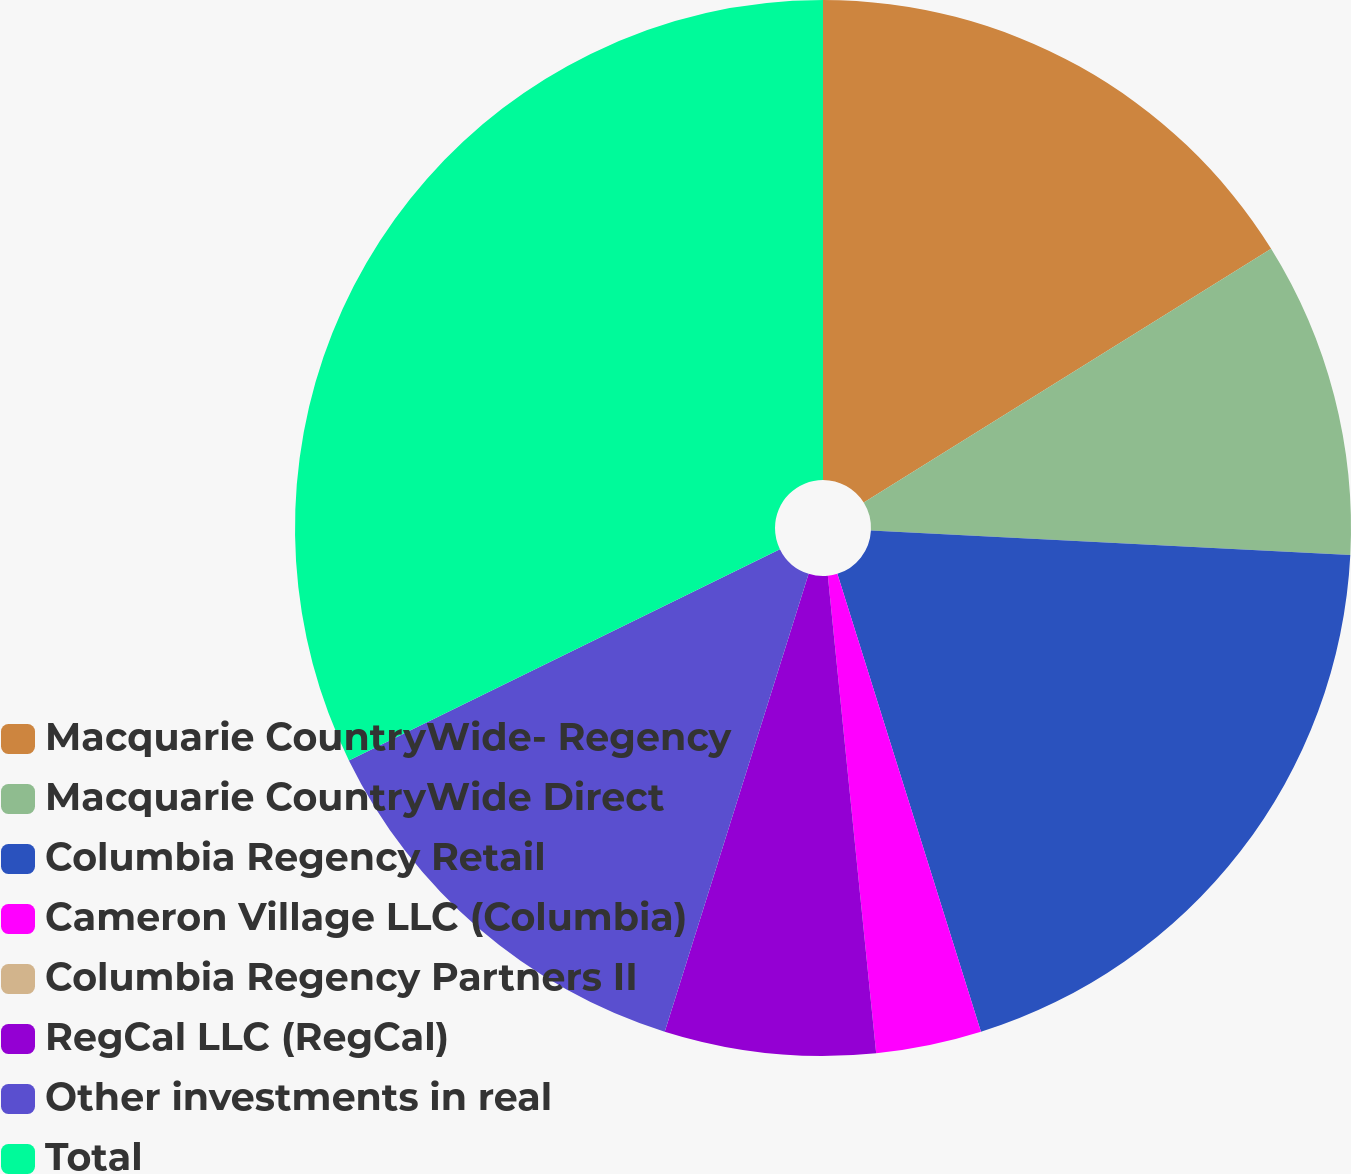Convert chart. <chart><loc_0><loc_0><loc_500><loc_500><pie_chart><fcel>Macquarie CountryWide- Regency<fcel>Macquarie CountryWide Direct<fcel>Columbia Regency Retail<fcel>Cameron Village LLC (Columbia)<fcel>Columbia Regency Partners II<fcel>RegCal LLC (RegCal)<fcel>Other investments in real<fcel>Total<nl><fcel>16.13%<fcel>9.68%<fcel>19.35%<fcel>3.23%<fcel>0.0%<fcel>6.45%<fcel>12.9%<fcel>32.25%<nl></chart> 